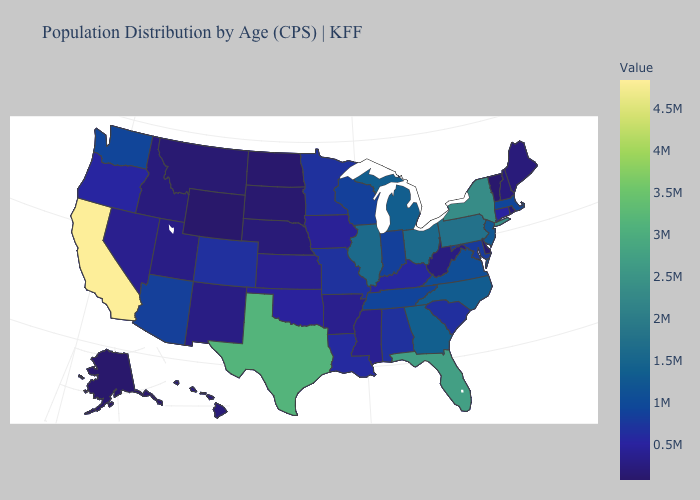Is the legend a continuous bar?
Concise answer only. Yes. Does Oregon have the highest value in the USA?
Keep it brief. No. Which states have the lowest value in the USA?
Answer briefly. Wyoming. Does Indiana have a higher value than Nebraska?
Be succinct. Yes. 